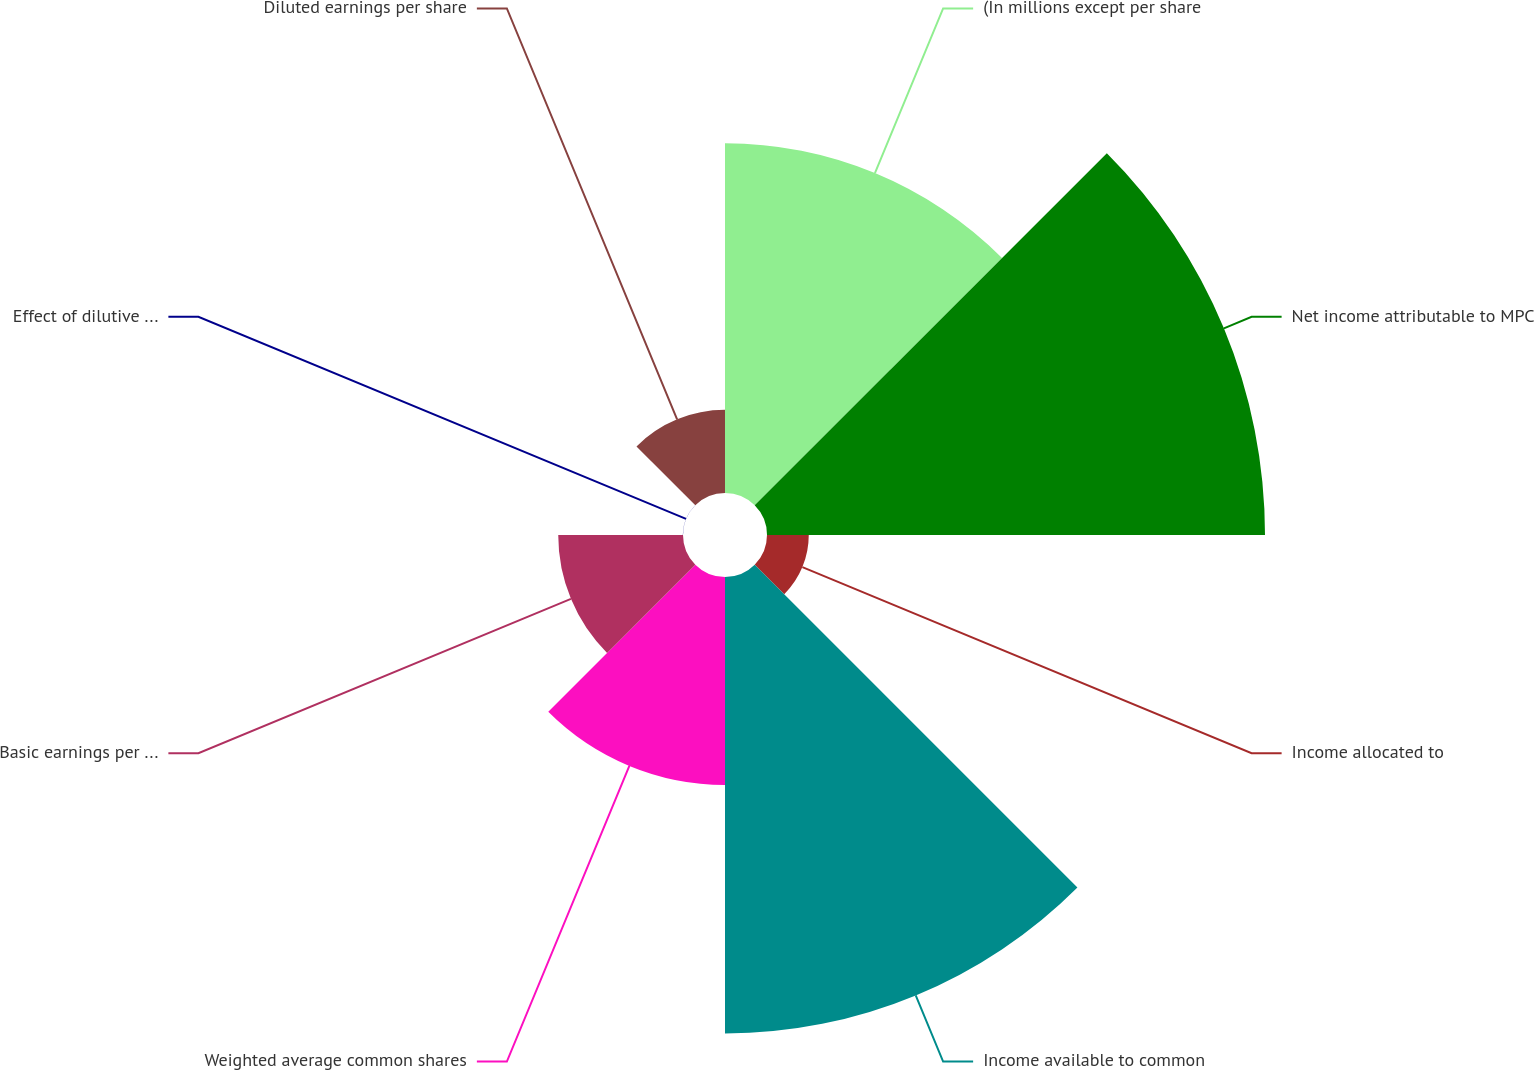Convert chart to OTSL. <chart><loc_0><loc_0><loc_500><loc_500><pie_chart><fcel>(In millions except per share<fcel>Net income attributable to MPC<fcel>Income allocated to<fcel>Income available to common<fcel>Weighted average common shares<fcel>Basic earnings per share<fcel>Effect of dilutive securities<fcel>Diluted earnings per share<nl><fcel>19.85%<fcel>28.26%<fcel>2.37%<fcel>25.9%<fcel>11.8%<fcel>7.08%<fcel>0.01%<fcel>4.72%<nl></chart> 